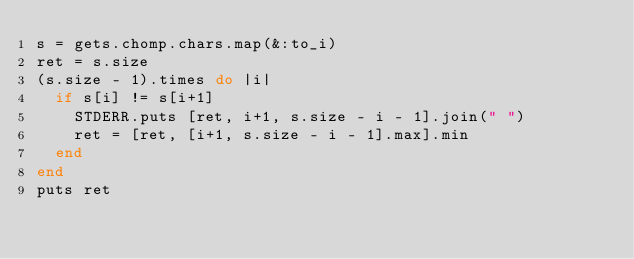Convert code to text. <code><loc_0><loc_0><loc_500><loc_500><_Ruby_>s = gets.chomp.chars.map(&:to_i)
ret = s.size
(s.size - 1).times do |i|
  if s[i] != s[i+1]
    STDERR.puts [ret, i+1, s.size - i - 1].join(" ")
    ret = [ret, [i+1, s.size - i - 1].max].min
  end
end
puts ret
</code> 